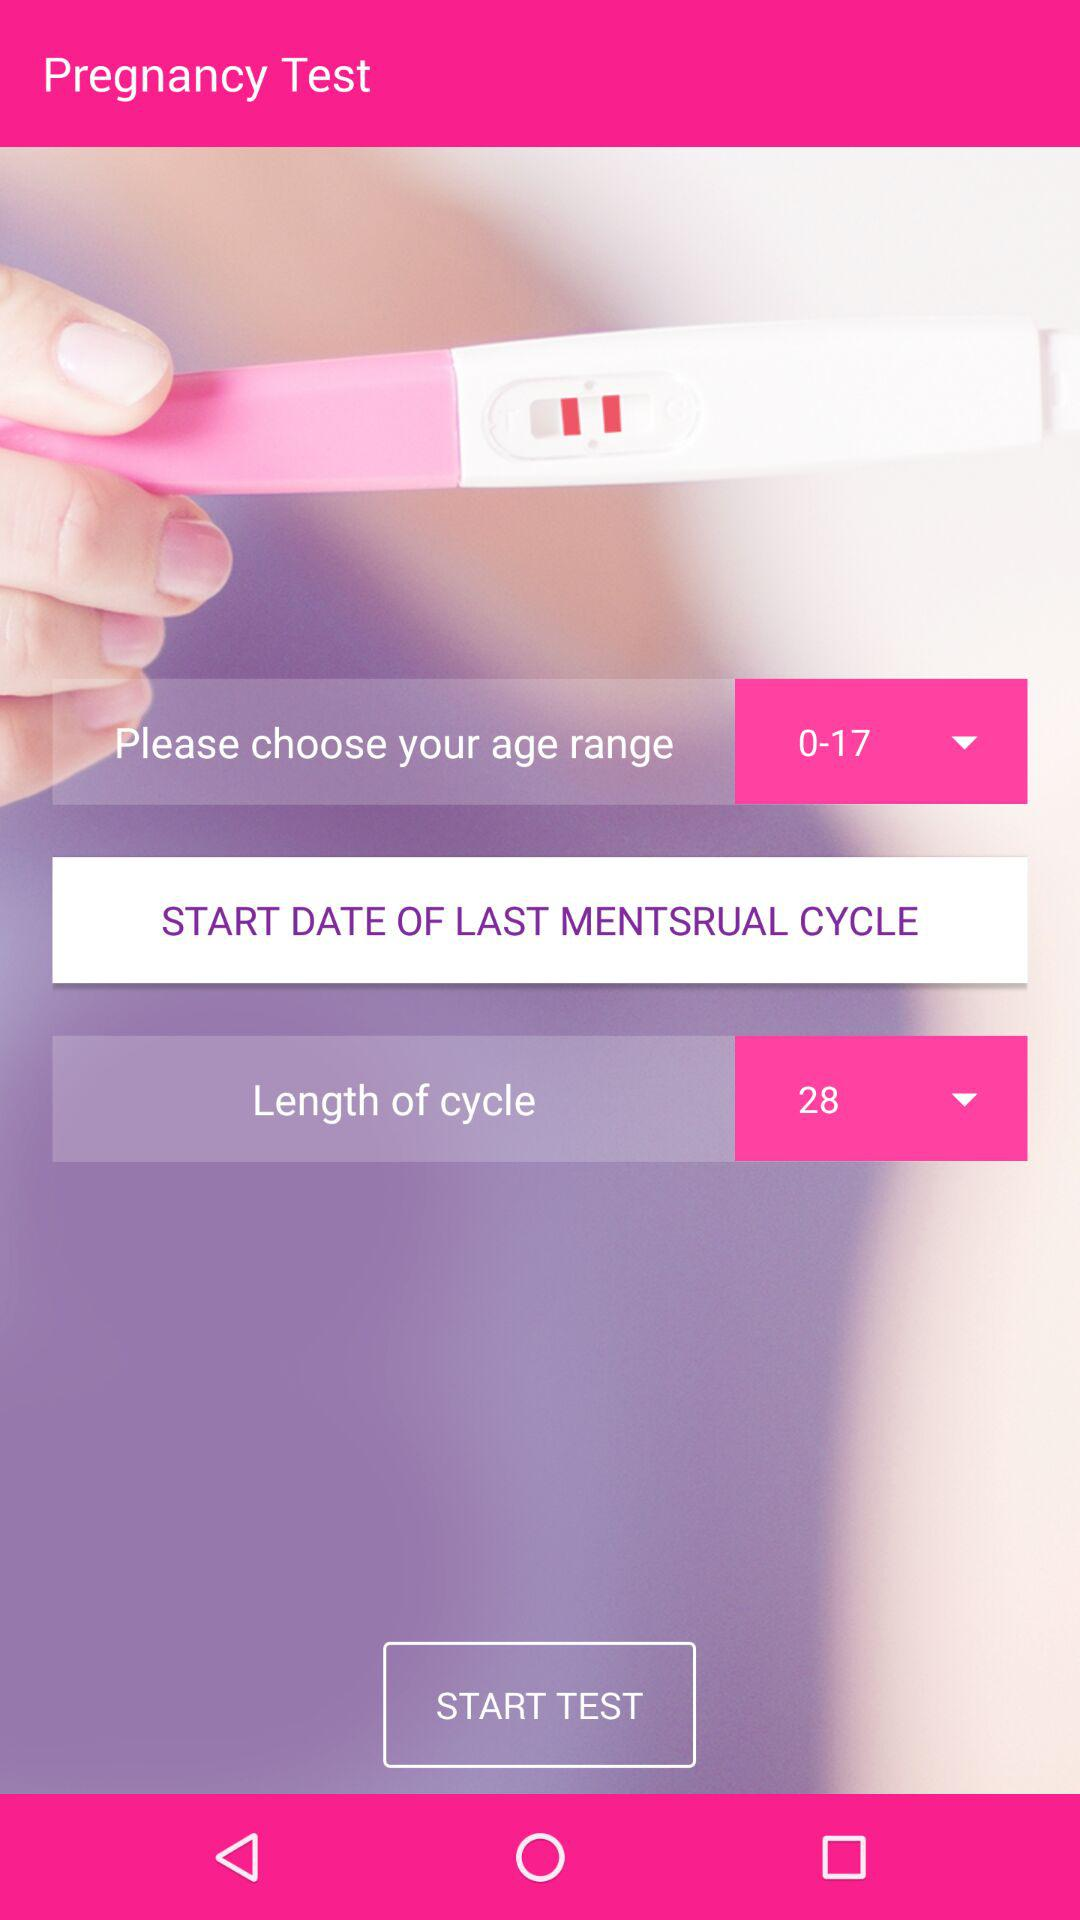How many questions are in the test?
When the provided information is insufficient, respond with <no answer>. <no answer> 